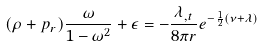Convert formula to latex. <formula><loc_0><loc_0><loc_500><loc_500>( \rho + p _ { r } ) \frac { \omega } { 1 - \omega ^ { 2 } } + \epsilon = - \frac { \lambda _ { , t } } { 8 \pi r } e ^ { - \frac { 1 } { 2 } ( \nu + \lambda ) }</formula> 